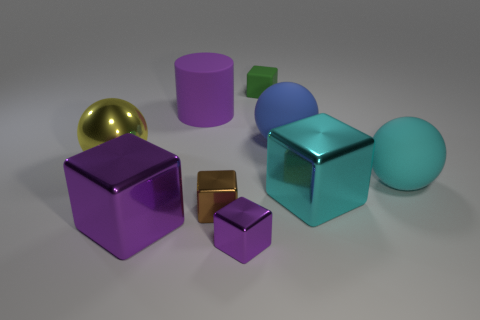Could you estimate the proportions of the objects in relation to each other? While it is challenging to provide exact measurements without a reference scale, we can make some educated guesses based on their relative sizes. The large purple cube could be considered a unit of measurement because it stands out due to its size. The metallic cube to its right might be half the unit in height. The rubber sphere and the smaller cube are roughly a quarter of the unit each. The rubber cylinder could be approximately one unit in height but half a unit in diameter. Lastly, the tiny green cube and the tiny purple block could be about an eighth of the unit each. 